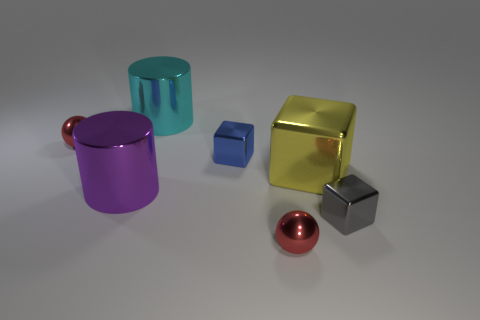The big cube that is made of the same material as the purple cylinder is what color?
Give a very brief answer. Yellow. There is a ball that is in front of the large purple cylinder; what size is it?
Give a very brief answer. Small. Is the number of gray metallic cubes behind the big yellow object less than the number of tiny brown metal balls?
Your answer should be compact. No. Are there any other things that are the same shape as the large cyan thing?
Your response must be concise. Yes. Are there fewer balls than large purple shiny things?
Make the answer very short. No. The ball that is behind the tiny gray metal cube that is right of the cyan metal object is what color?
Offer a terse response. Red. There is a red ball behind the tiny blue shiny object that is to the right of the shiny cylinder that is behind the big yellow shiny object; what is it made of?
Your answer should be compact. Metal. There is a purple cylinder that is on the left side of the yellow thing; is its size the same as the blue block?
Make the answer very short. No. There is a sphere that is behind the small blue cube; what is its material?
Give a very brief answer. Metal. Are there more shiny cylinders than big cyan matte balls?
Your answer should be very brief. Yes. 